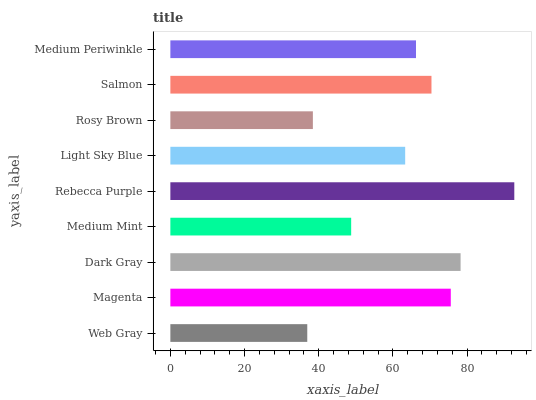Is Web Gray the minimum?
Answer yes or no. Yes. Is Rebecca Purple the maximum?
Answer yes or no. Yes. Is Magenta the minimum?
Answer yes or no. No. Is Magenta the maximum?
Answer yes or no. No. Is Magenta greater than Web Gray?
Answer yes or no. Yes. Is Web Gray less than Magenta?
Answer yes or no. Yes. Is Web Gray greater than Magenta?
Answer yes or no. No. Is Magenta less than Web Gray?
Answer yes or no. No. Is Medium Periwinkle the high median?
Answer yes or no. Yes. Is Medium Periwinkle the low median?
Answer yes or no. Yes. Is Medium Mint the high median?
Answer yes or no. No. Is Salmon the low median?
Answer yes or no. No. 